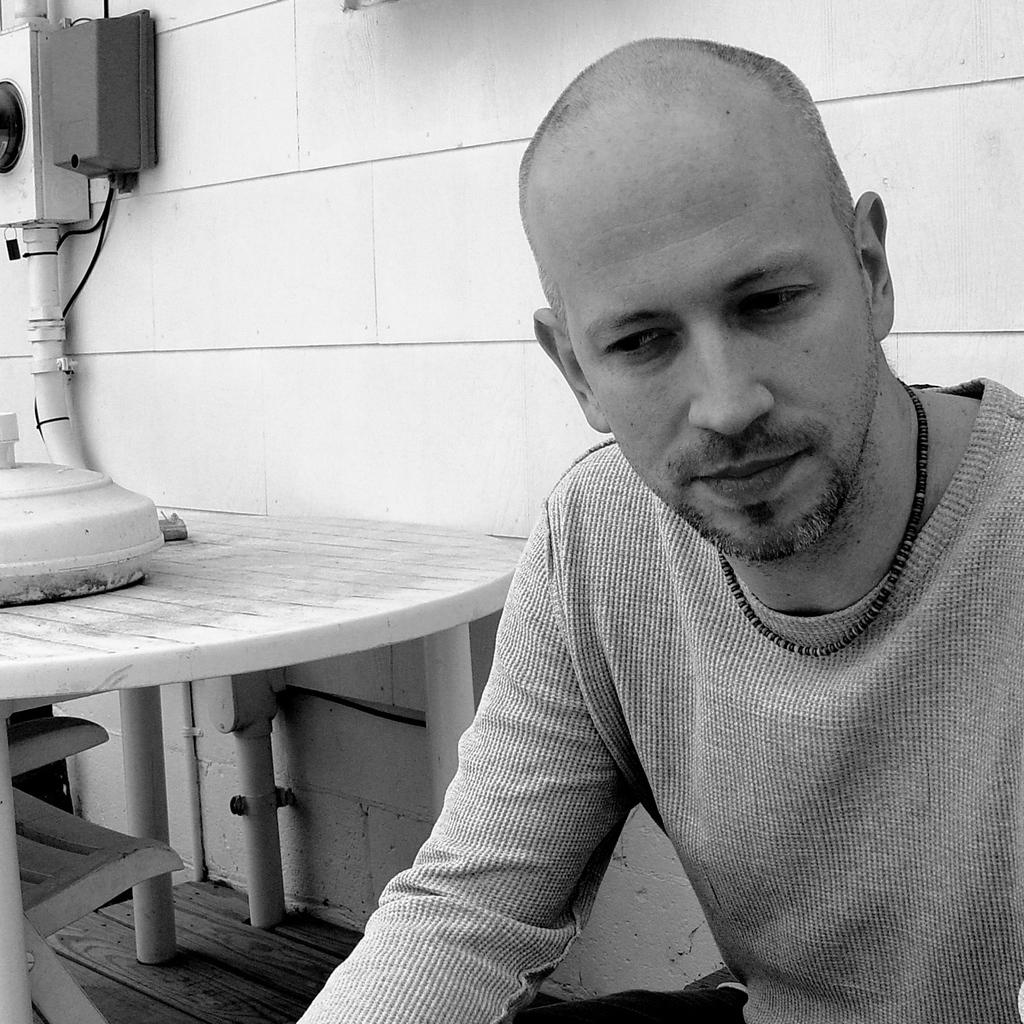Who or what is the main subject in the image? There is a person in the image. What objects can be seen in the background? There is a box on a table, a chair, another box, and a pipe on the wall in the background. What color is the ice in the person's eye in the image? There is no ice or eye mentioned in the image; it only describes a person and objects in the background. 